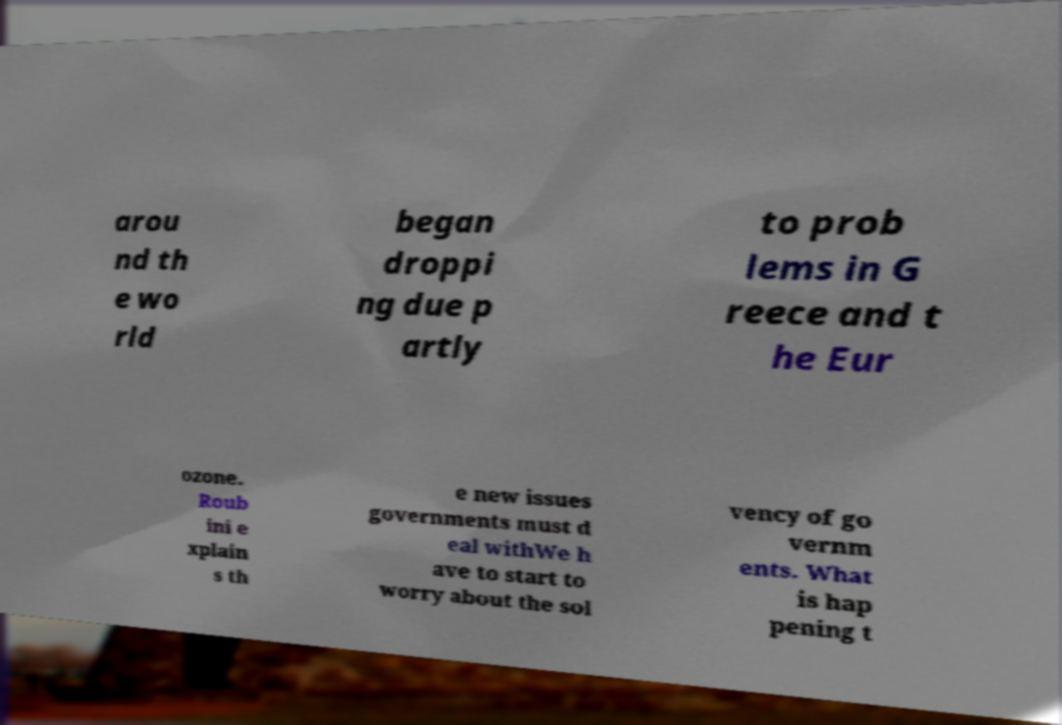Could you extract and type out the text from this image? arou nd th e wo rld began droppi ng due p artly to prob lems in G reece and t he Eur ozone. Roub ini e xplain s th e new issues governments must d eal withWe h ave to start to worry about the sol vency of go vernm ents. What is hap pening t 